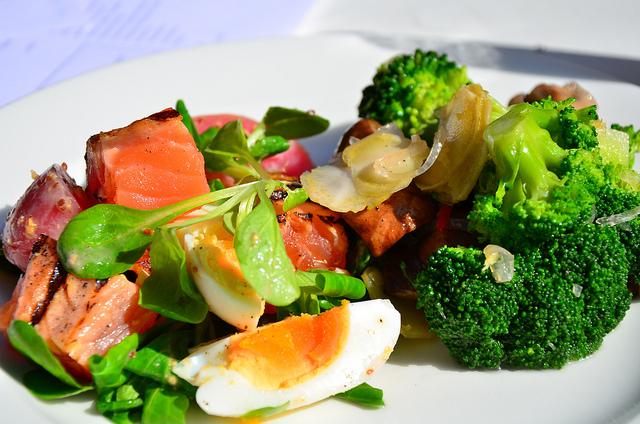What seafood is on the plate?
Write a very short answer. Salmon. Is there an egg on the plate?
Short answer required. Yes. Does it appear salt or pepper has been used on this dish?
Answer briefly. No. What color is the broccoli?
Quick response, please. Green. 